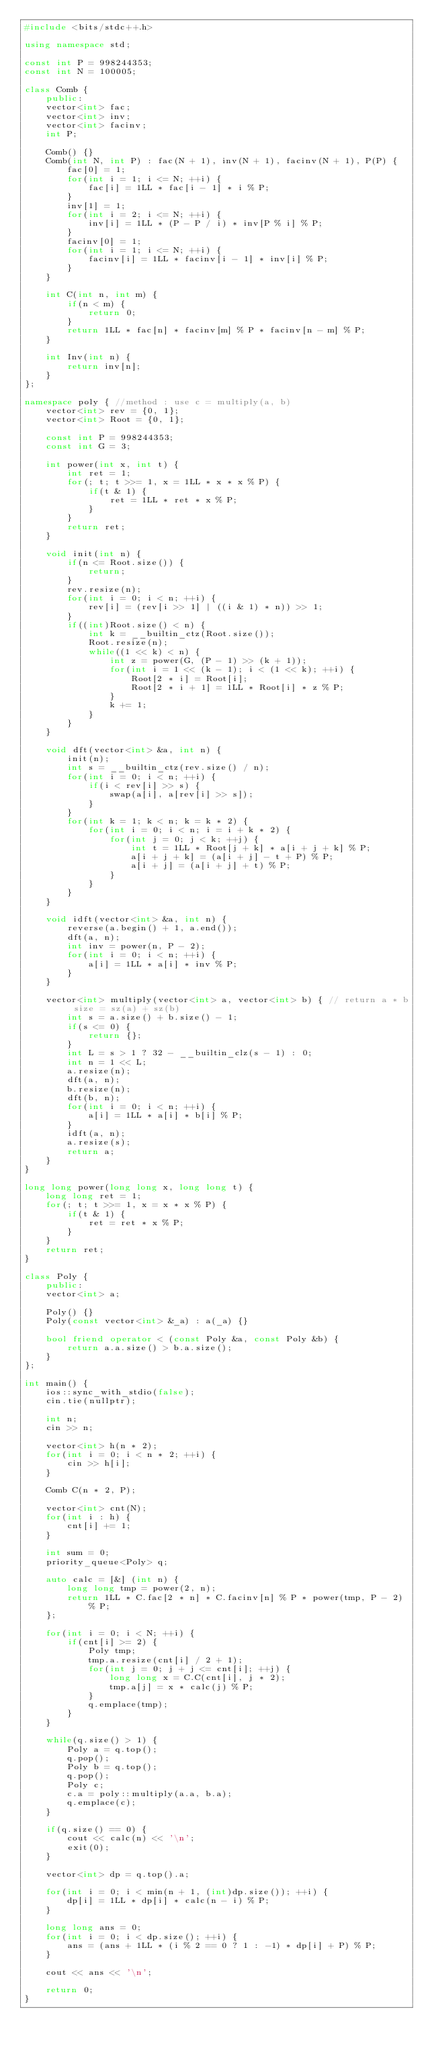Convert code to text. <code><loc_0><loc_0><loc_500><loc_500><_C++_>#include <bits/stdc++.h>

using namespace std;

const int P = 998244353;
const int N = 100005;

class Comb {
	public:
    vector<int> fac;
    vector<int> inv;
    vector<int> facinv;
    int P;

    Comb() {}
    Comb(int N, int P) : fac(N + 1), inv(N + 1), facinv(N + 1), P(P) {
        fac[0] = 1;
        for(int i = 1; i <= N; ++i) {
            fac[i] = 1LL * fac[i - 1] * i % P;
        }
        inv[1] = 1;
        for(int i = 2; i <= N; ++i) {
            inv[i] = 1LL * (P - P / i) * inv[P % i] % P;
        }
        facinv[0] = 1;
        for(int i = 1; i <= N; ++i) {
            facinv[i] = 1LL * facinv[i - 1] * inv[i] % P;
        }
    }

    int C(int n, int m) {
        if(n < m) {
            return 0;
        }
        return 1LL * fac[n] * facinv[m] % P * facinv[n - m] % P;
    }

    int Inv(int n) {
        return inv[n];
    }
};

namespace poly { //method : use c = multiply(a, b)
    vector<int> rev = {0, 1};
    vector<int> Root = {0, 1};

    const int P = 998244353;
    const int G = 3;

    int power(int x, int t) {
        int ret = 1;
        for(; t; t >>= 1, x = 1LL * x * x % P) {
            if(t & 1) {
                ret = 1LL * ret * x % P;
            }
        }
        return ret;
    }

    void init(int n) {
        if(n <= Root.size()) {
            return;
        }
        rev.resize(n);
        for(int i = 0; i < n; ++i) {
            rev[i] = (rev[i >> 1] | ((i & 1) * n)) >> 1;
        }
        if((int)Root.size() < n) {
            int k = __builtin_ctz(Root.size());
            Root.resize(n);
            while((1 << k) < n) {
                int z = power(G, (P - 1) >> (k + 1));
                for(int i = 1 << (k - 1); i < (1 << k); ++i) {
                    Root[2 * i] = Root[i];
                    Root[2 * i + 1] = 1LL * Root[i] * z % P;
                }
                k += 1;
            }
        }
    }

    void dft(vector<int> &a, int n) {
        init(n);
        int s = __builtin_ctz(rev.size() / n);
        for(int i = 0; i < n; ++i) {
            if(i < rev[i] >> s) {
                swap(a[i], a[rev[i] >> s]);
            }
        }
        for(int k = 1; k < n; k = k * 2) {
            for(int i = 0; i < n; i = i + k * 2) {
                for(int j = 0; j < k; ++j) {
                    int t = 1LL * Root[j + k] * a[i + j + k] % P;
                    a[i + j + k] = (a[i + j] - t + P) % P;
                    a[i + j] = (a[i + j] + t) % P; 
                }
            }
        }
    }

    void idft(vector<int> &a, int n) {
        reverse(a.begin() + 1, a.end());
        dft(a, n);
        int inv = power(n, P - 2);
        for(int i = 0; i < n; ++i) {
            a[i] = 1LL * a[i] * inv % P;
        }
    }

    vector<int> multiply(vector<int> a, vector<int> b) { // return a * b size = sz(a) + sz(b)
        int s = a.size() + b.size() - 1;
        if(s <= 0) {
            return {};
        }
        int L = s > 1 ? 32 - __builtin_clz(s - 1) : 0;
        int n = 1 << L;
        a.resize(n);
        dft(a, n);
        b.resize(n);
        dft(b, n);
        for(int i = 0; i < n; ++i) {
            a[i] = 1LL * a[i] * b[i] % P;
        }
        idft(a, n);
        a.resize(s);
        return a;
    }
}

long long power(long long x, long long t) {
	long long ret = 1;
	for(; t; t >>= 1, x = x * x % P) {
		if(t & 1) {
			ret = ret * x % P;
		}
	}
	return ret;
}

class Poly {
	public:
	vector<int> a;

	Poly() {}
	Poly(const vector<int> &_a) : a(_a) {}

	bool friend operator < (const Poly &a, const Poly &b) {
		return a.a.size() > b.a.size();
	}
};

int main() {
	ios::sync_with_stdio(false);
	cin.tie(nullptr);

	int n;
	cin >> n;

	vector<int> h(n * 2);
	for(int i = 0; i < n * 2; ++i) {
		cin >> h[i];
	}

	Comb C(n * 2, P);		

	vector<int> cnt(N);
	for(int i : h) {
		cnt[i] += 1;
	}

	int sum = 0;
	priority_queue<Poly> q;

	auto calc = [&] (int n) {
		long long tmp = power(2, n);
		return 1LL * C.fac[2 * n] * C.facinv[n] % P * power(tmp, P - 2) % P;
	};	

	for(int i = 0; i < N; ++i) {
		if(cnt[i] >= 2) {
			Poly tmp;
			tmp.a.resize(cnt[i] / 2 + 1);
			for(int j = 0; j + j <= cnt[i]; ++j) {
				long long x = C.C(cnt[i], j * 2);
				tmp.a[j] = x * calc(j) % P;
			}
			q.emplace(tmp);
		}
	}

	while(q.size() > 1) {
		Poly a = q.top();
		q.pop();
		Poly b = q.top();
		q.pop();
		Poly c;
		c.a = poly::multiply(a.a, b.a);
		q.emplace(c);
	}

	if(q.size() == 0) {
		cout << calc(n) << '\n';
		exit(0);
	}

	vector<int> dp = q.top().a;

	for(int i = 0; i < min(n + 1, (int)dp.size()); ++i) {
		dp[i] = 1LL * dp[i] * calc(n - i) % P;
	}

	long long ans = 0;
	for(int i = 0; i < dp.size(); ++i) {
		ans = (ans + 1LL * (i % 2 == 0 ? 1 : -1) * dp[i] + P) % P;
	}

	cout << ans << '\n';

	return 0;
}
</code> 